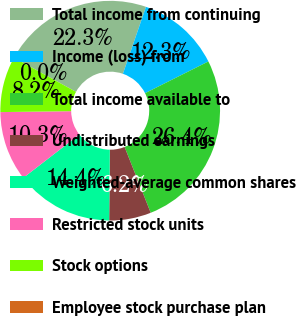Convert chart. <chart><loc_0><loc_0><loc_500><loc_500><pie_chart><fcel>Total income from continuing<fcel>Income (loss) from<fcel>Total income available to<fcel>Undistributed earnings<fcel>Weighted-average common shares<fcel>Restricted stock units<fcel>Stock options<fcel>Employee stock purchase plan<nl><fcel>22.28%<fcel>12.32%<fcel>26.38%<fcel>6.16%<fcel>14.38%<fcel>10.27%<fcel>8.21%<fcel>0.0%<nl></chart> 